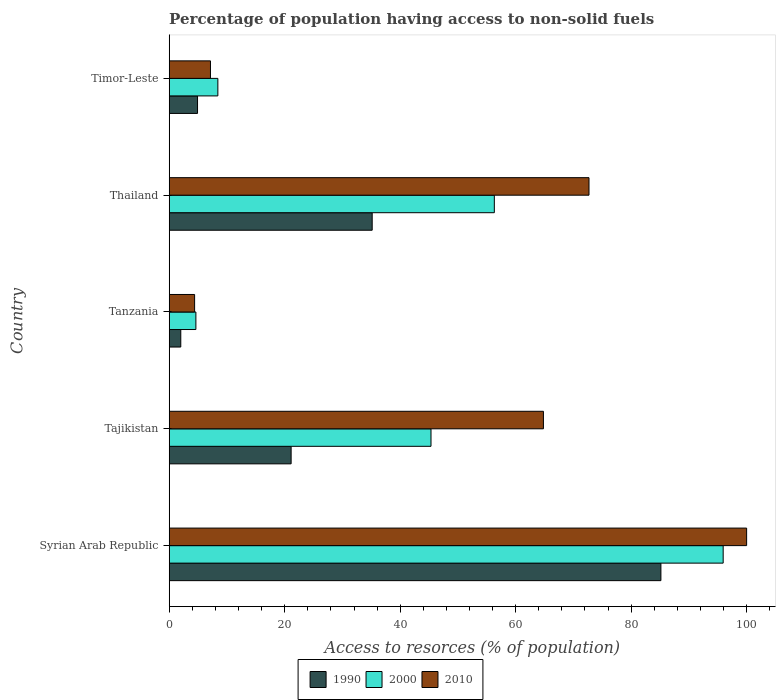How many different coloured bars are there?
Your answer should be very brief. 3. Are the number of bars on each tick of the Y-axis equal?
Offer a very short reply. Yes. How many bars are there on the 5th tick from the top?
Give a very brief answer. 3. How many bars are there on the 3rd tick from the bottom?
Your response must be concise. 3. What is the label of the 4th group of bars from the top?
Your answer should be compact. Tajikistan. In how many cases, is the number of bars for a given country not equal to the number of legend labels?
Offer a very short reply. 0. What is the percentage of population having access to non-solid fuels in 1990 in Timor-Leste?
Provide a succinct answer. 4.9. Across all countries, what is the maximum percentage of population having access to non-solid fuels in 1990?
Your response must be concise. 85.15. Across all countries, what is the minimum percentage of population having access to non-solid fuels in 1990?
Make the answer very short. 2.01. In which country was the percentage of population having access to non-solid fuels in 2000 maximum?
Your answer should be very brief. Syrian Arab Republic. In which country was the percentage of population having access to non-solid fuels in 1990 minimum?
Give a very brief answer. Tanzania. What is the total percentage of population having access to non-solid fuels in 2000 in the graph?
Make the answer very short. 210.61. What is the difference between the percentage of population having access to non-solid fuels in 2000 in Syrian Arab Republic and that in Tajikistan?
Offer a terse response. 50.59. What is the difference between the percentage of population having access to non-solid fuels in 2010 in Timor-Leste and the percentage of population having access to non-solid fuels in 2000 in Tanzania?
Your answer should be compact. 2.52. What is the average percentage of population having access to non-solid fuels in 2000 per country?
Provide a succinct answer. 42.12. What is the difference between the percentage of population having access to non-solid fuels in 2000 and percentage of population having access to non-solid fuels in 2010 in Tajikistan?
Make the answer very short. -19.47. In how many countries, is the percentage of population having access to non-solid fuels in 2000 greater than 92 %?
Offer a terse response. 1. What is the ratio of the percentage of population having access to non-solid fuels in 2010 in Tajikistan to that in Timor-Leste?
Provide a short and direct response. 9.07. Is the percentage of population having access to non-solid fuels in 1990 in Syrian Arab Republic less than that in Timor-Leste?
Provide a succinct answer. No. Is the difference between the percentage of population having access to non-solid fuels in 2000 in Thailand and Timor-Leste greater than the difference between the percentage of population having access to non-solid fuels in 2010 in Thailand and Timor-Leste?
Give a very brief answer. No. What is the difference between the highest and the second highest percentage of population having access to non-solid fuels in 2010?
Offer a very short reply. 27.29. What is the difference between the highest and the lowest percentage of population having access to non-solid fuels in 1990?
Your answer should be very brief. 83.14. Is it the case that in every country, the sum of the percentage of population having access to non-solid fuels in 2000 and percentage of population having access to non-solid fuels in 1990 is greater than the percentage of population having access to non-solid fuels in 2010?
Ensure brevity in your answer.  Yes. What is the difference between two consecutive major ticks on the X-axis?
Offer a very short reply. 20. Are the values on the major ticks of X-axis written in scientific E-notation?
Make the answer very short. No. How many legend labels are there?
Offer a very short reply. 3. How are the legend labels stacked?
Make the answer very short. Horizontal. What is the title of the graph?
Your answer should be very brief. Percentage of population having access to non-solid fuels. What is the label or title of the X-axis?
Provide a succinct answer. Access to resorces (% of population). What is the Access to resorces (% of population) of 1990 in Syrian Arab Republic?
Your answer should be compact. 85.15. What is the Access to resorces (% of population) in 2000 in Syrian Arab Republic?
Offer a very short reply. 95.93. What is the Access to resorces (% of population) of 2010 in Syrian Arab Republic?
Ensure brevity in your answer.  99.99. What is the Access to resorces (% of population) in 1990 in Tajikistan?
Your answer should be very brief. 21.11. What is the Access to resorces (% of population) of 2000 in Tajikistan?
Ensure brevity in your answer.  45.34. What is the Access to resorces (% of population) of 2010 in Tajikistan?
Your answer should be compact. 64.8. What is the Access to resorces (% of population) of 1990 in Tanzania?
Provide a succinct answer. 2.01. What is the Access to resorces (% of population) in 2000 in Tanzania?
Ensure brevity in your answer.  4.62. What is the Access to resorces (% of population) in 2010 in Tanzania?
Provide a succinct answer. 4.4. What is the Access to resorces (% of population) of 1990 in Thailand?
Keep it short and to the point. 35.15. What is the Access to resorces (% of population) of 2000 in Thailand?
Offer a very short reply. 56.3. What is the Access to resorces (% of population) in 2010 in Thailand?
Your answer should be very brief. 72.7. What is the Access to resorces (% of population) in 1990 in Timor-Leste?
Provide a succinct answer. 4.9. What is the Access to resorces (% of population) in 2000 in Timor-Leste?
Your answer should be compact. 8.43. What is the Access to resorces (% of population) of 2010 in Timor-Leste?
Keep it short and to the point. 7.14. Across all countries, what is the maximum Access to resorces (% of population) of 1990?
Ensure brevity in your answer.  85.15. Across all countries, what is the maximum Access to resorces (% of population) of 2000?
Provide a succinct answer. 95.93. Across all countries, what is the maximum Access to resorces (% of population) in 2010?
Offer a terse response. 99.99. Across all countries, what is the minimum Access to resorces (% of population) in 1990?
Give a very brief answer. 2.01. Across all countries, what is the minimum Access to resorces (% of population) of 2000?
Ensure brevity in your answer.  4.62. Across all countries, what is the minimum Access to resorces (% of population) of 2010?
Your response must be concise. 4.4. What is the total Access to resorces (% of population) in 1990 in the graph?
Make the answer very short. 148.32. What is the total Access to resorces (% of population) in 2000 in the graph?
Offer a very short reply. 210.61. What is the total Access to resorces (% of population) in 2010 in the graph?
Provide a succinct answer. 249.03. What is the difference between the Access to resorces (% of population) of 1990 in Syrian Arab Republic and that in Tajikistan?
Ensure brevity in your answer.  64.04. What is the difference between the Access to resorces (% of population) in 2000 in Syrian Arab Republic and that in Tajikistan?
Your answer should be very brief. 50.59. What is the difference between the Access to resorces (% of population) of 2010 in Syrian Arab Republic and that in Tajikistan?
Offer a terse response. 35.19. What is the difference between the Access to resorces (% of population) in 1990 in Syrian Arab Republic and that in Tanzania?
Keep it short and to the point. 83.14. What is the difference between the Access to resorces (% of population) of 2000 in Syrian Arab Republic and that in Tanzania?
Ensure brevity in your answer.  91.31. What is the difference between the Access to resorces (% of population) in 2010 in Syrian Arab Republic and that in Tanzania?
Give a very brief answer. 95.59. What is the difference between the Access to resorces (% of population) in 1990 in Syrian Arab Republic and that in Thailand?
Your answer should be very brief. 50. What is the difference between the Access to resorces (% of population) in 2000 in Syrian Arab Republic and that in Thailand?
Offer a very short reply. 39.63. What is the difference between the Access to resorces (% of population) of 2010 in Syrian Arab Republic and that in Thailand?
Your answer should be compact. 27.29. What is the difference between the Access to resorces (% of population) of 1990 in Syrian Arab Republic and that in Timor-Leste?
Offer a terse response. 80.24. What is the difference between the Access to resorces (% of population) in 2000 in Syrian Arab Republic and that in Timor-Leste?
Ensure brevity in your answer.  87.5. What is the difference between the Access to resorces (% of population) of 2010 in Syrian Arab Republic and that in Timor-Leste?
Keep it short and to the point. 92.85. What is the difference between the Access to resorces (% of population) in 1990 in Tajikistan and that in Tanzania?
Your answer should be compact. 19.11. What is the difference between the Access to resorces (% of population) in 2000 in Tajikistan and that in Tanzania?
Provide a short and direct response. 40.72. What is the difference between the Access to resorces (% of population) of 2010 in Tajikistan and that in Tanzania?
Give a very brief answer. 60.4. What is the difference between the Access to resorces (% of population) of 1990 in Tajikistan and that in Thailand?
Your response must be concise. -14.04. What is the difference between the Access to resorces (% of population) of 2000 in Tajikistan and that in Thailand?
Offer a terse response. -10.96. What is the difference between the Access to resorces (% of population) in 2010 in Tajikistan and that in Thailand?
Your response must be concise. -7.89. What is the difference between the Access to resorces (% of population) of 1990 in Tajikistan and that in Timor-Leste?
Your answer should be very brief. 16.21. What is the difference between the Access to resorces (% of population) of 2000 in Tajikistan and that in Timor-Leste?
Give a very brief answer. 36.91. What is the difference between the Access to resorces (% of population) in 2010 in Tajikistan and that in Timor-Leste?
Provide a succinct answer. 57.66. What is the difference between the Access to resorces (% of population) of 1990 in Tanzania and that in Thailand?
Make the answer very short. -33.15. What is the difference between the Access to resorces (% of population) in 2000 in Tanzania and that in Thailand?
Ensure brevity in your answer.  -51.68. What is the difference between the Access to resorces (% of population) of 2010 in Tanzania and that in Thailand?
Give a very brief answer. -68.3. What is the difference between the Access to resorces (% of population) in 1990 in Tanzania and that in Timor-Leste?
Offer a terse response. -2.9. What is the difference between the Access to resorces (% of population) in 2000 in Tanzania and that in Timor-Leste?
Offer a terse response. -3.81. What is the difference between the Access to resorces (% of population) of 2010 in Tanzania and that in Timor-Leste?
Offer a very short reply. -2.75. What is the difference between the Access to resorces (% of population) of 1990 in Thailand and that in Timor-Leste?
Provide a succinct answer. 30.25. What is the difference between the Access to resorces (% of population) of 2000 in Thailand and that in Timor-Leste?
Provide a succinct answer. 47.87. What is the difference between the Access to resorces (% of population) in 2010 in Thailand and that in Timor-Leste?
Your response must be concise. 65.55. What is the difference between the Access to resorces (% of population) of 1990 in Syrian Arab Republic and the Access to resorces (% of population) of 2000 in Tajikistan?
Provide a short and direct response. 39.81. What is the difference between the Access to resorces (% of population) of 1990 in Syrian Arab Republic and the Access to resorces (% of population) of 2010 in Tajikistan?
Offer a terse response. 20.34. What is the difference between the Access to resorces (% of population) in 2000 in Syrian Arab Republic and the Access to resorces (% of population) in 2010 in Tajikistan?
Give a very brief answer. 31.13. What is the difference between the Access to resorces (% of population) in 1990 in Syrian Arab Republic and the Access to resorces (% of population) in 2000 in Tanzania?
Provide a succinct answer. 80.53. What is the difference between the Access to resorces (% of population) in 1990 in Syrian Arab Republic and the Access to resorces (% of population) in 2010 in Tanzania?
Offer a terse response. 80.75. What is the difference between the Access to resorces (% of population) in 2000 in Syrian Arab Republic and the Access to resorces (% of population) in 2010 in Tanzania?
Your answer should be compact. 91.53. What is the difference between the Access to resorces (% of population) of 1990 in Syrian Arab Republic and the Access to resorces (% of population) of 2000 in Thailand?
Keep it short and to the point. 28.85. What is the difference between the Access to resorces (% of population) of 1990 in Syrian Arab Republic and the Access to resorces (% of population) of 2010 in Thailand?
Ensure brevity in your answer.  12.45. What is the difference between the Access to resorces (% of population) in 2000 in Syrian Arab Republic and the Access to resorces (% of population) in 2010 in Thailand?
Ensure brevity in your answer.  23.24. What is the difference between the Access to resorces (% of population) in 1990 in Syrian Arab Republic and the Access to resorces (% of population) in 2000 in Timor-Leste?
Give a very brief answer. 76.72. What is the difference between the Access to resorces (% of population) in 1990 in Syrian Arab Republic and the Access to resorces (% of population) in 2010 in Timor-Leste?
Provide a succinct answer. 78. What is the difference between the Access to resorces (% of population) of 2000 in Syrian Arab Republic and the Access to resorces (% of population) of 2010 in Timor-Leste?
Keep it short and to the point. 88.79. What is the difference between the Access to resorces (% of population) of 1990 in Tajikistan and the Access to resorces (% of population) of 2000 in Tanzania?
Provide a short and direct response. 16.49. What is the difference between the Access to resorces (% of population) in 1990 in Tajikistan and the Access to resorces (% of population) in 2010 in Tanzania?
Ensure brevity in your answer.  16.71. What is the difference between the Access to resorces (% of population) of 2000 in Tajikistan and the Access to resorces (% of population) of 2010 in Tanzania?
Ensure brevity in your answer.  40.94. What is the difference between the Access to resorces (% of population) of 1990 in Tajikistan and the Access to resorces (% of population) of 2000 in Thailand?
Provide a short and direct response. -35.19. What is the difference between the Access to resorces (% of population) in 1990 in Tajikistan and the Access to resorces (% of population) in 2010 in Thailand?
Your answer should be very brief. -51.58. What is the difference between the Access to resorces (% of population) of 2000 in Tajikistan and the Access to resorces (% of population) of 2010 in Thailand?
Provide a short and direct response. -27.36. What is the difference between the Access to resorces (% of population) of 1990 in Tajikistan and the Access to resorces (% of population) of 2000 in Timor-Leste?
Keep it short and to the point. 12.69. What is the difference between the Access to resorces (% of population) in 1990 in Tajikistan and the Access to resorces (% of population) in 2010 in Timor-Leste?
Your answer should be compact. 13.97. What is the difference between the Access to resorces (% of population) of 2000 in Tajikistan and the Access to resorces (% of population) of 2010 in Timor-Leste?
Provide a short and direct response. 38.19. What is the difference between the Access to resorces (% of population) in 1990 in Tanzania and the Access to resorces (% of population) in 2000 in Thailand?
Offer a terse response. -54.3. What is the difference between the Access to resorces (% of population) of 1990 in Tanzania and the Access to resorces (% of population) of 2010 in Thailand?
Offer a very short reply. -70.69. What is the difference between the Access to resorces (% of population) in 2000 in Tanzania and the Access to resorces (% of population) in 2010 in Thailand?
Offer a very short reply. -68.08. What is the difference between the Access to resorces (% of population) in 1990 in Tanzania and the Access to resorces (% of population) in 2000 in Timor-Leste?
Keep it short and to the point. -6.42. What is the difference between the Access to resorces (% of population) in 1990 in Tanzania and the Access to resorces (% of population) in 2010 in Timor-Leste?
Your answer should be very brief. -5.14. What is the difference between the Access to resorces (% of population) in 2000 in Tanzania and the Access to resorces (% of population) in 2010 in Timor-Leste?
Your response must be concise. -2.52. What is the difference between the Access to resorces (% of population) of 1990 in Thailand and the Access to resorces (% of population) of 2000 in Timor-Leste?
Make the answer very short. 26.72. What is the difference between the Access to resorces (% of population) in 1990 in Thailand and the Access to resorces (% of population) in 2010 in Timor-Leste?
Make the answer very short. 28.01. What is the difference between the Access to resorces (% of population) of 2000 in Thailand and the Access to resorces (% of population) of 2010 in Timor-Leste?
Provide a short and direct response. 49.16. What is the average Access to resorces (% of population) in 1990 per country?
Provide a short and direct response. 29.66. What is the average Access to resorces (% of population) in 2000 per country?
Your response must be concise. 42.12. What is the average Access to resorces (% of population) of 2010 per country?
Give a very brief answer. 49.81. What is the difference between the Access to resorces (% of population) of 1990 and Access to resorces (% of population) of 2000 in Syrian Arab Republic?
Provide a succinct answer. -10.78. What is the difference between the Access to resorces (% of population) of 1990 and Access to resorces (% of population) of 2010 in Syrian Arab Republic?
Your response must be concise. -14.84. What is the difference between the Access to resorces (% of population) in 2000 and Access to resorces (% of population) in 2010 in Syrian Arab Republic?
Keep it short and to the point. -4.06. What is the difference between the Access to resorces (% of population) in 1990 and Access to resorces (% of population) in 2000 in Tajikistan?
Offer a very short reply. -24.22. What is the difference between the Access to resorces (% of population) of 1990 and Access to resorces (% of population) of 2010 in Tajikistan?
Make the answer very short. -43.69. What is the difference between the Access to resorces (% of population) in 2000 and Access to resorces (% of population) in 2010 in Tajikistan?
Make the answer very short. -19.47. What is the difference between the Access to resorces (% of population) of 1990 and Access to resorces (% of population) of 2000 in Tanzania?
Provide a succinct answer. -2.62. What is the difference between the Access to resorces (% of population) in 1990 and Access to resorces (% of population) in 2010 in Tanzania?
Your response must be concise. -2.39. What is the difference between the Access to resorces (% of population) in 2000 and Access to resorces (% of population) in 2010 in Tanzania?
Your response must be concise. 0.22. What is the difference between the Access to resorces (% of population) of 1990 and Access to resorces (% of population) of 2000 in Thailand?
Your response must be concise. -21.15. What is the difference between the Access to resorces (% of population) in 1990 and Access to resorces (% of population) in 2010 in Thailand?
Give a very brief answer. -37.54. What is the difference between the Access to resorces (% of population) of 2000 and Access to resorces (% of population) of 2010 in Thailand?
Provide a short and direct response. -16.39. What is the difference between the Access to resorces (% of population) in 1990 and Access to resorces (% of population) in 2000 in Timor-Leste?
Your answer should be compact. -3.52. What is the difference between the Access to resorces (% of population) of 1990 and Access to resorces (% of population) of 2010 in Timor-Leste?
Make the answer very short. -2.24. What is the difference between the Access to resorces (% of population) in 2000 and Access to resorces (% of population) in 2010 in Timor-Leste?
Make the answer very short. 1.28. What is the ratio of the Access to resorces (% of population) in 1990 in Syrian Arab Republic to that in Tajikistan?
Your answer should be very brief. 4.03. What is the ratio of the Access to resorces (% of population) in 2000 in Syrian Arab Republic to that in Tajikistan?
Your response must be concise. 2.12. What is the ratio of the Access to resorces (% of population) in 2010 in Syrian Arab Republic to that in Tajikistan?
Provide a succinct answer. 1.54. What is the ratio of the Access to resorces (% of population) of 1990 in Syrian Arab Republic to that in Tanzania?
Give a very brief answer. 42.47. What is the ratio of the Access to resorces (% of population) in 2000 in Syrian Arab Republic to that in Tanzania?
Provide a short and direct response. 20.76. What is the ratio of the Access to resorces (% of population) in 2010 in Syrian Arab Republic to that in Tanzania?
Your response must be concise. 22.73. What is the ratio of the Access to resorces (% of population) in 1990 in Syrian Arab Republic to that in Thailand?
Your response must be concise. 2.42. What is the ratio of the Access to resorces (% of population) in 2000 in Syrian Arab Republic to that in Thailand?
Your answer should be compact. 1.7. What is the ratio of the Access to resorces (% of population) of 2010 in Syrian Arab Republic to that in Thailand?
Your answer should be very brief. 1.38. What is the ratio of the Access to resorces (% of population) of 1990 in Syrian Arab Republic to that in Timor-Leste?
Offer a terse response. 17.36. What is the ratio of the Access to resorces (% of population) in 2000 in Syrian Arab Republic to that in Timor-Leste?
Offer a terse response. 11.38. What is the ratio of the Access to resorces (% of population) of 2010 in Syrian Arab Republic to that in Timor-Leste?
Give a very brief answer. 14. What is the ratio of the Access to resorces (% of population) of 1990 in Tajikistan to that in Tanzania?
Your response must be concise. 10.53. What is the ratio of the Access to resorces (% of population) of 2000 in Tajikistan to that in Tanzania?
Give a very brief answer. 9.81. What is the ratio of the Access to resorces (% of population) of 2010 in Tajikistan to that in Tanzania?
Your answer should be very brief. 14.73. What is the ratio of the Access to resorces (% of population) in 1990 in Tajikistan to that in Thailand?
Give a very brief answer. 0.6. What is the ratio of the Access to resorces (% of population) of 2000 in Tajikistan to that in Thailand?
Keep it short and to the point. 0.81. What is the ratio of the Access to resorces (% of population) of 2010 in Tajikistan to that in Thailand?
Ensure brevity in your answer.  0.89. What is the ratio of the Access to resorces (% of population) of 1990 in Tajikistan to that in Timor-Leste?
Your response must be concise. 4.31. What is the ratio of the Access to resorces (% of population) of 2000 in Tajikistan to that in Timor-Leste?
Offer a very short reply. 5.38. What is the ratio of the Access to resorces (% of population) in 2010 in Tajikistan to that in Timor-Leste?
Offer a very short reply. 9.07. What is the ratio of the Access to resorces (% of population) of 1990 in Tanzania to that in Thailand?
Your answer should be compact. 0.06. What is the ratio of the Access to resorces (% of population) of 2000 in Tanzania to that in Thailand?
Ensure brevity in your answer.  0.08. What is the ratio of the Access to resorces (% of population) in 2010 in Tanzania to that in Thailand?
Ensure brevity in your answer.  0.06. What is the ratio of the Access to resorces (% of population) in 1990 in Tanzania to that in Timor-Leste?
Your answer should be very brief. 0.41. What is the ratio of the Access to resorces (% of population) in 2000 in Tanzania to that in Timor-Leste?
Your response must be concise. 0.55. What is the ratio of the Access to resorces (% of population) of 2010 in Tanzania to that in Timor-Leste?
Give a very brief answer. 0.62. What is the ratio of the Access to resorces (% of population) in 1990 in Thailand to that in Timor-Leste?
Ensure brevity in your answer.  7.17. What is the ratio of the Access to resorces (% of population) in 2000 in Thailand to that in Timor-Leste?
Offer a very short reply. 6.68. What is the ratio of the Access to resorces (% of population) in 2010 in Thailand to that in Timor-Leste?
Your answer should be very brief. 10.18. What is the difference between the highest and the second highest Access to resorces (% of population) in 1990?
Provide a succinct answer. 50. What is the difference between the highest and the second highest Access to resorces (% of population) in 2000?
Offer a terse response. 39.63. What is the difference between the highest and the second highest Access to resorces (% of population) in 2010?
Your answer should be compact. 27.29. What is the difference between the highest and the lowest Access to resorces (% of population) of 1990?
Offer a very short reply. 83.14. What is the difference between the highest and the lowest Access to resorces (% of population) in 2000?
Offer a very short reply. 91.31. What is the difference between the highest and the lowest Access to resorces (% of population) of 2010?
Ensure brevity in your answer.  95.59. 